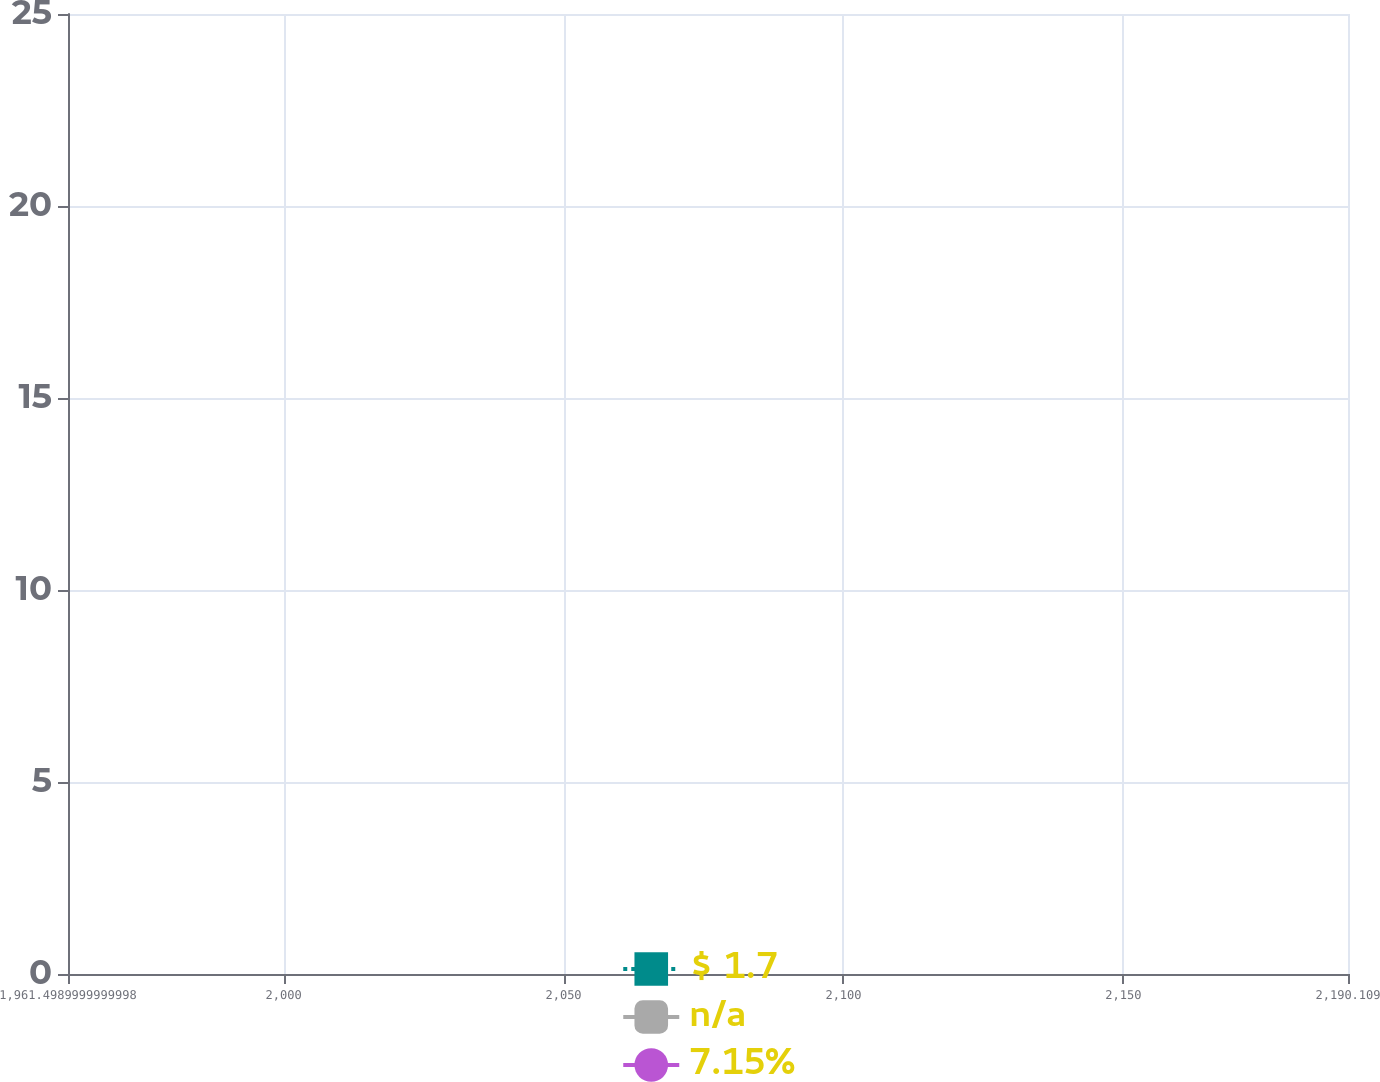Convert chart to OTSL. <chart><loc_0><loc_0><loc_500><loc_500><line_chart><ecel><fcel>$ 1.7<fcel>n/a<fcel>7.15%<nl><fcel>1984.36<fcel>6.16<fcel>2.1<fcel>16.21<nl><fcel>2007.22<fcel>5.78<fcel>2.15<fcel>20.1<nl><fcel>2212.97<fcel>4.76<fcel>2.17<fcel>20.5<nl></chart> 